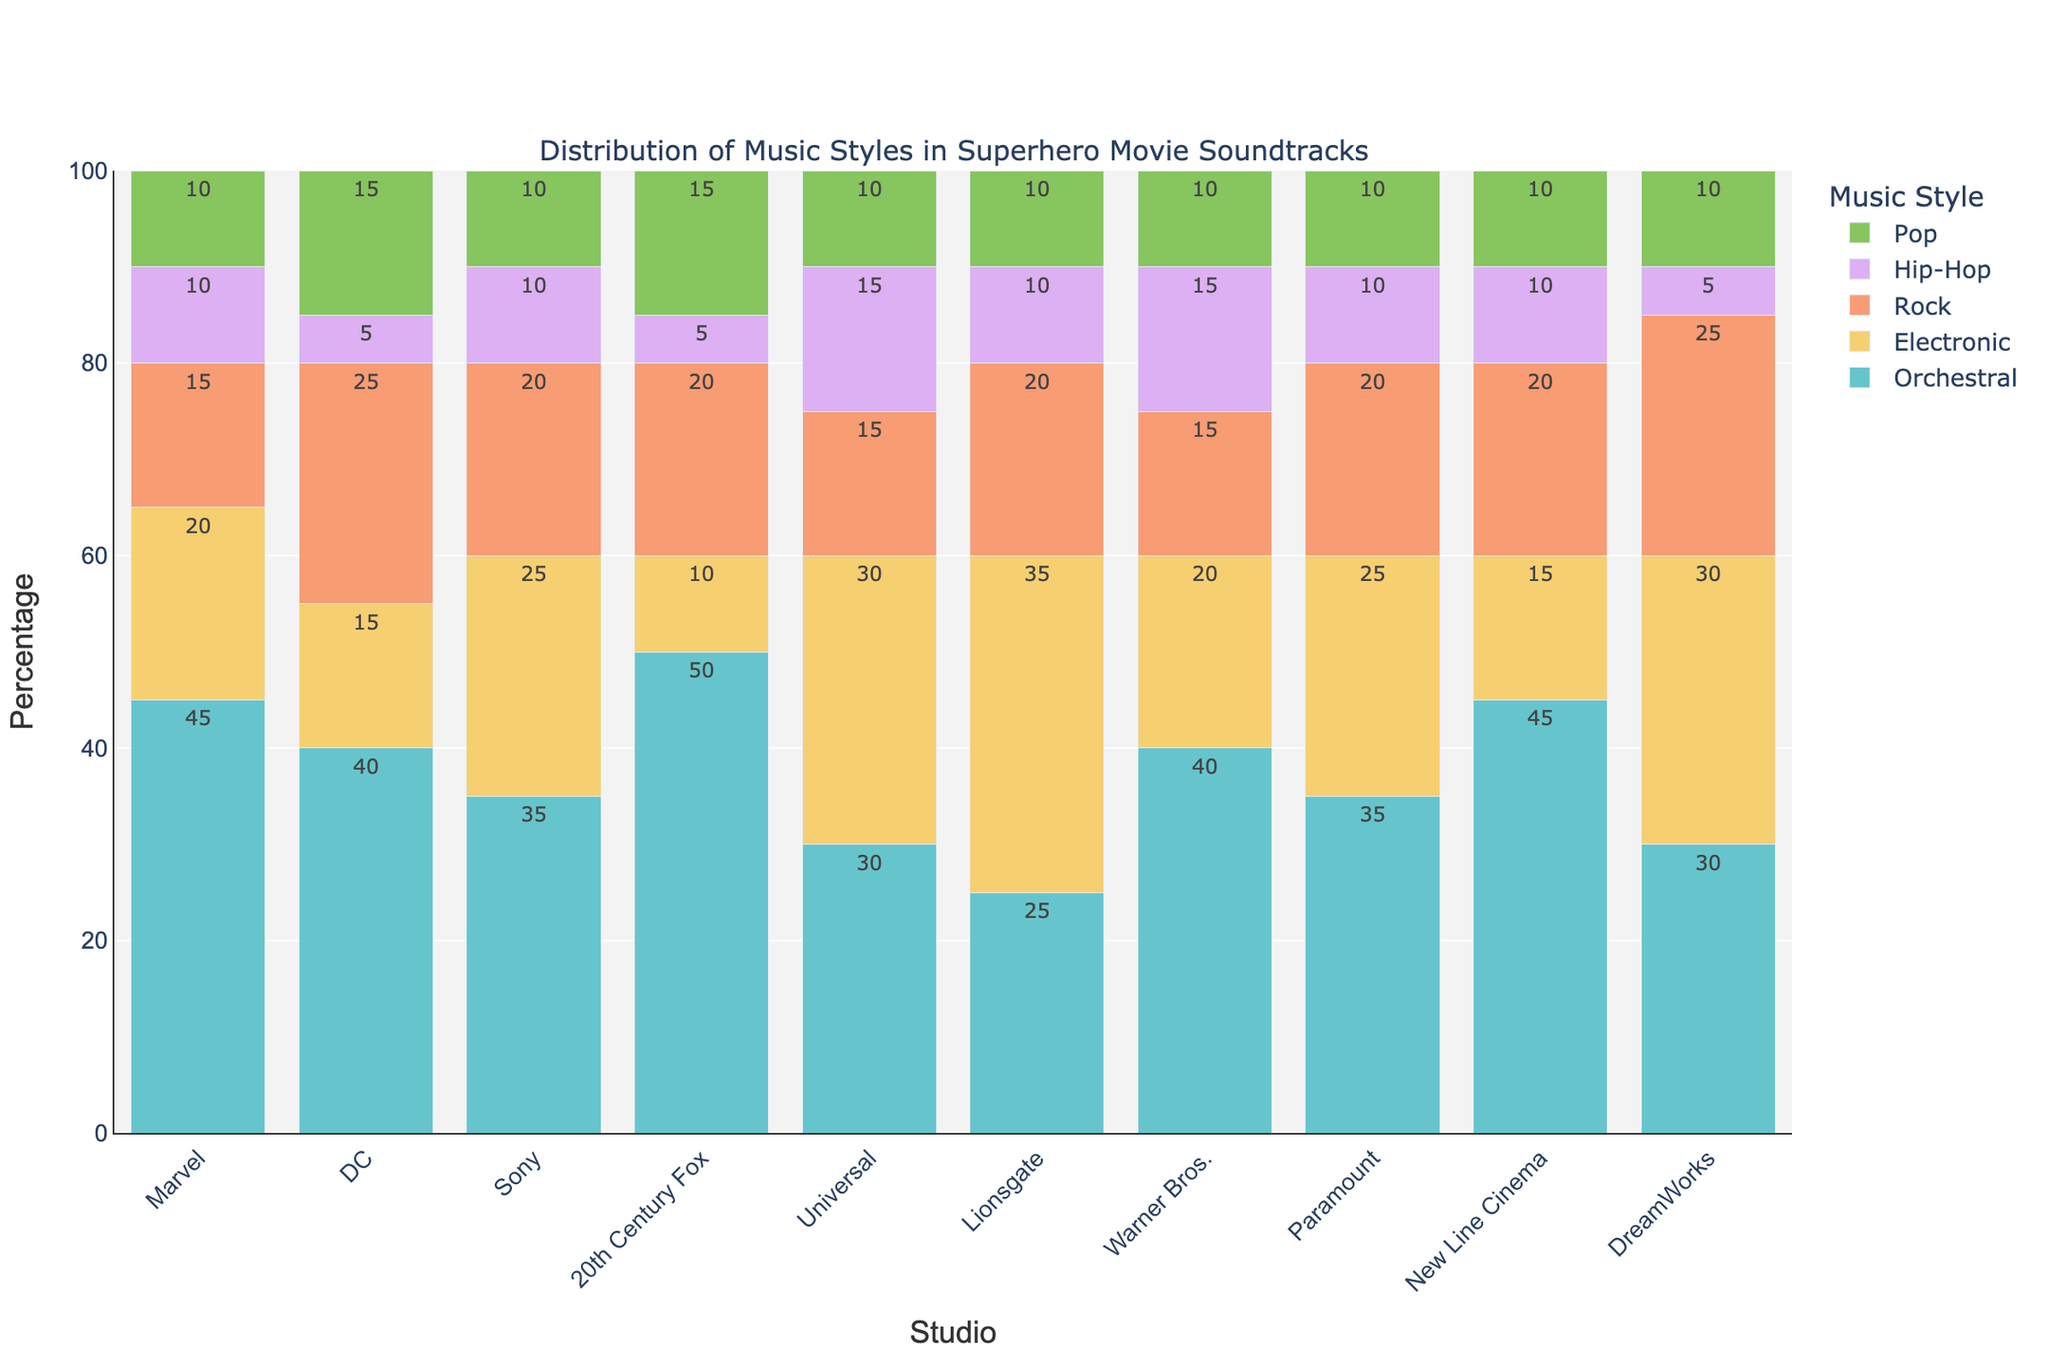What is the total percentage of Orchestral music style across all studios? Sum the percentages of Orchestral music for all studios: 45 (Marvel) + 40 (DC) + 35 (Sony) + 50 (20th Century Fox) + 30 (Universal) + 25 (Lionsgate) + 40 (Warner Bros.) + 35 (Paramount) + 45 (New Line Cinema) + 30 (DreamWorks) = 375%
Answer: 375% Which studio has the highest percentage of Electronic music? Compare the percentages of Electronic music across all studios: 20 (Marvel), 15 (DC), 25 (Sony), 10 (20th Century Fox), 30 (Universal), 35 (Lionsgate), 20 (Warner Bros.), 25 (Paramount), 15 (New Line Cinema), 30 (DreamWorks). Lionsgate has the highest percentage.
Answer: Lionsgate How does the percentage of Hip-Hop music in Universal compare to that in Marvel? Check percentage of Hip-Hop in Universal (15) and Marvel (10). Universal has a higher percentage.
Answer: Universal has a higher percentage Which studios have an equal percentage of Pop music? Compare the percentages of Pop music: Marvel (10), DC (15), Sony (10), 20th Century Fox (15), Universal (10), Lionsgate (10), Warner Bros. (10), Paramount (10), New Line Cinema (10), DreamWorks (10). Marvel, Sony, Universal, Lionsgate, Warner Bros., Paramount, New Line Cinema, and DreamWorks all have the same percentage of Pop music.
Answer: Marvel, Sony, Universal, Lionsgate, Warner Bros., Paramount, New Line Cinema, DreamWorks What is the percentage difference in Rock music between DC and Marvel? Compute the percentage of Rock music for DC (25) and Marvel (15) and subtract Marvel's from DC's: 25 - 15 = 10
Answer: 10 Which music style has the least percentage representation across all studios? Compare the total percentages of each music style: Orchestral (375), Electronic (225), Rock (195), Hip-Hop (95), Pop (120). Hip-Hop has the least representation.
Answer: Hip-Hop What is the average percentage of Rock music across all studios? Sum the percentages of Rock music: 15 (Marvel) + 25 (DC) + 20 (Sony) + 20 (20th Century Fox) + 15 (Universal) + 20 (Lionsgate) + 15 (Warner Bros.) + 20 (Paramount) + 20 (New Line Cinema) + 25 (DreamWorks) = 195. Divide by the number of studios (10): 195 / 10 = 19.5
Answer: 19.5 Which studio has the greatest total combination of Orchestral and Electronic music? Combine Orchestral and Electronic for each studio: Marvel (45 + 20 = 65), DC (40 + 15 = 55), Sony (35 + 25 = 60), 20th Century Fox (50 + 10 = 60), Universal (30 + 30 = 60), Lionsgate (25 + 35 = 60), Warner Bros. (40 + 20 = 60), Paramount (35 + 25 = 60), New Line Cinema (45 + 15 = 60), DreamWorks (30 + 30 = 60). Marvel has the highest total combination.
Answer: Marvel Which studios use Pop music more than DC? Compare the percentages of Pop music in DC (15) with other studios: Marvel (10), Sony (10), 20th Century Fox (15), Universal (10), Lionsgate (10), Warner Bros. (10), Paramount (10), New Line Cinema (10), DreamWorks (10). None of the studios use Pop music more than DC.
Answer: None What is the total percentage of non-Orchestral music styles for DreamWorks? Sum the percentages of Electronic, Rock, Hip-Hop, and Pop for DreamWorks: 30 + 25 + 5 + 10 = 70
Answer: 70 